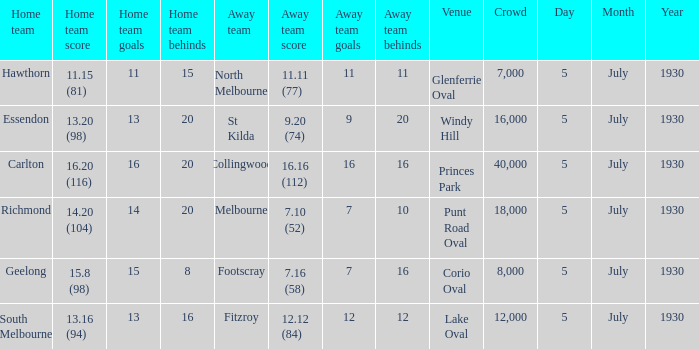I'm looking to parse the entire table for insights. Could you assist me with that? {'header': ['Home team', 'Home team score', 'Home team goals', 'Home team behinds', 'Away team', 'Away team score', 'Away team goals', 'Away team behinds', 'Venue', 'Crowd', 'Day', 'Month', 'Year'], 'rows': [['Hawthorn', '11.15 (81)', '11', '15', 'North Melbourne', '11.11 (77)', '11', '11', 'Glenferrie Oval', '7,000', '5', 'July', '1930'], ['Essendon', '13.20 (98)', '13', '20', 'St Kilda', '9.20 (74)', '9', '20', 'Windy Hill', '16,000', '5', 'July', '1930'], ['Carlton', '16.20 (116)', '16', '20', 'Collingwood', '16.16 (112)', '16', '16', 'Princes Park', '40,000', '5', 'July', '1930'], ['Richmond', '14.20 (104)', '14', '20', 'Melbourne', '7.10 (52)', '7', '10', 'Punt Road Oval', '18,000', '5', 'July', '1930'], ['Geelong', '15.8 (98)', '15', '8', 'Footscray', '7.16 (58)', '7', '16', 'Corio Oval', '8,000', '5', 'July', '1930'], ['South Melbourne', '13.16 (94)', '13', '16', 'Fitzroy', '12.12 (84)', '12', '12', 'Lake Oval', '12,000', '5', 'July', '1930']]} What is the day of the team's match at punt road oval? 5 July 1930. 